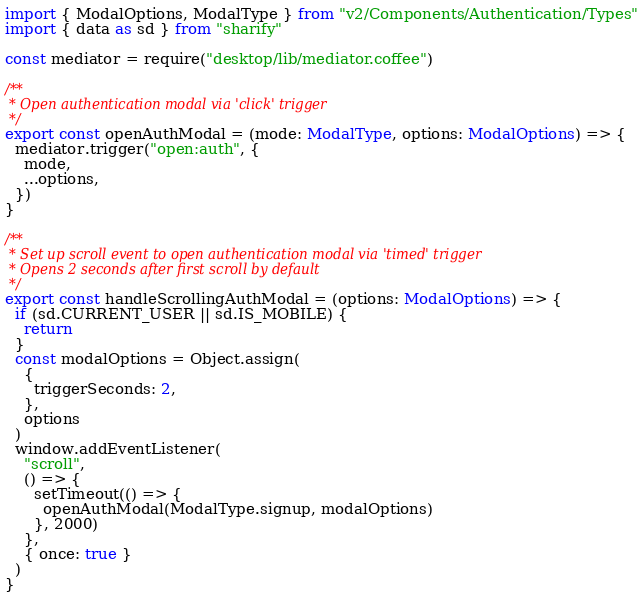<code> <loc_0><loc_0><loc_500><loc_500><_TypeScript_>import { ModalOptions, ModalType } from "v2/Components/Authentication/Types"
import { data as sd } from "sharify"

const mediator = require("desktop/lib/mediator.coffee")

/**
 * Open authentication modal via 'click' trigger
 */
export const openAuthModal = (mode: ModalType, options: ModalOptions) => {
  mediator.trigger("open:auth", {
    mode,
    ...options,
  })
}

/**
 * Set up scroll event to open authentication modal via 'timed' trigger
 * Opens 2 seconds after first scroll by default
 */
export const handleScrollingAuthModal = (options: ModalOptions) => {
  if (sd.CURRENT_USER || sd.IS_MOBILE) {
    return
  }
  const modalOptions = Object.assign(
    {
      triggerSeconds: 2,
    },
    options
  )
  window.addEventListener(
    "scroll",
    () => {
      setTimeout(() => {
        openAuthModal(ModalType.signup, modalOptions)
      }, 2000)
    },
    { once: true }
  )
}
</code> 